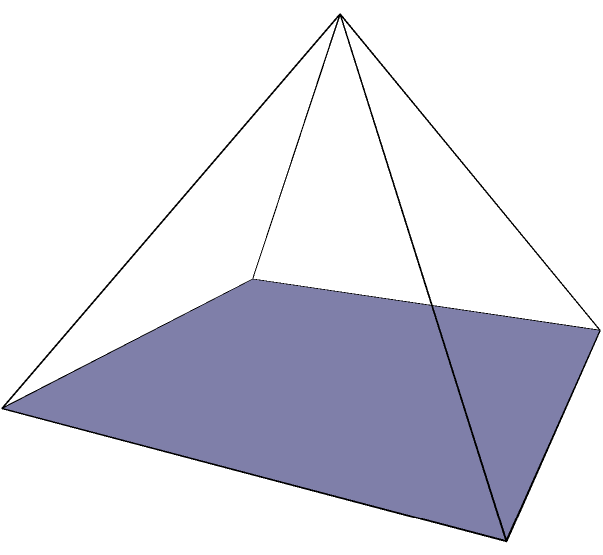A pyramid represents the percentage of female protagonists in different video game genres. The square base has sides of 8 units, representing various genres, and the height is 6 units, symbolizing the maximum representation. If this pyramid represents 100% of the game market, what percentage of games have female protagonists, assuming uniform distribution across genres? To solve this problem, we need to calculate the volume of the pyramid and compare it to the volume of a cube with the same base. This will give us the percentage of female representation.

Step 1: Calculate the volume of the pyramid
The formula for the volume of a pyramid is:
$$V_{pyramid} = \frac{1}{3} \times B \times h$$
where $B$ is the area of the base and $h$ is the height.

$B = 8 \times 8 = 64$ square units
$h = 6$ units

$$V_{pyramid} = \frac{1}{3} \times 64 \times 6 = 128$$ cubic units

Step 2: Calculate the volume of a cube with the same base
$$V_{cube} = 8 \times 8 \times 8 = 512$$ cubic units

Step 3: Calculate the percentage
Percentage = $\frac{V_{pyramid}}{V_{cube}} \times 100\%$
$$\frac{128}{512} \times 100\% = 0.25 \times 100\% = 25\%$$

Therefore, the pyramid represents 25% of the total possible volume, indicating that 25% of games across genres have female protagonists.
Answer: 25% 